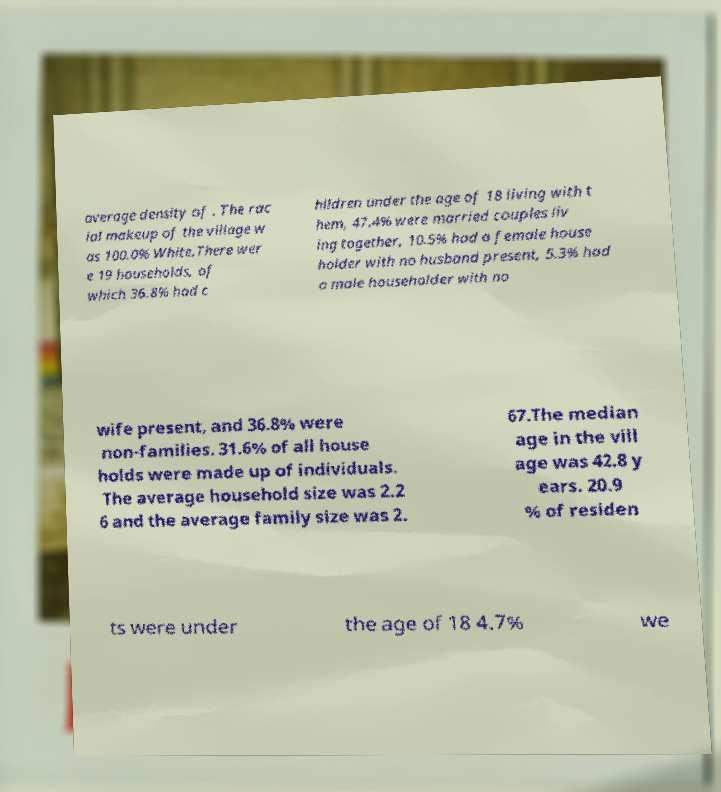Could you extract and type out the text from this image? average density of . The rac ial makeup of the village w as 100.0% White.There wer e 19 households, of which 36.8% had c hildren under the age of 18 living with t hem, 47.4% were married couples liv ing together, 10.5% had a female house holder with no husband present, 5.3% had a male householder with no wife present, and 36.8% were non-families. 31.6% of all house holds were made up of individuals. The average household size was 2.2 6 and the average family size was 2. 67.The median age in the vill age was 42.8 y ears. 20.9 % of residen ts were under the age of 18 4.7% we 